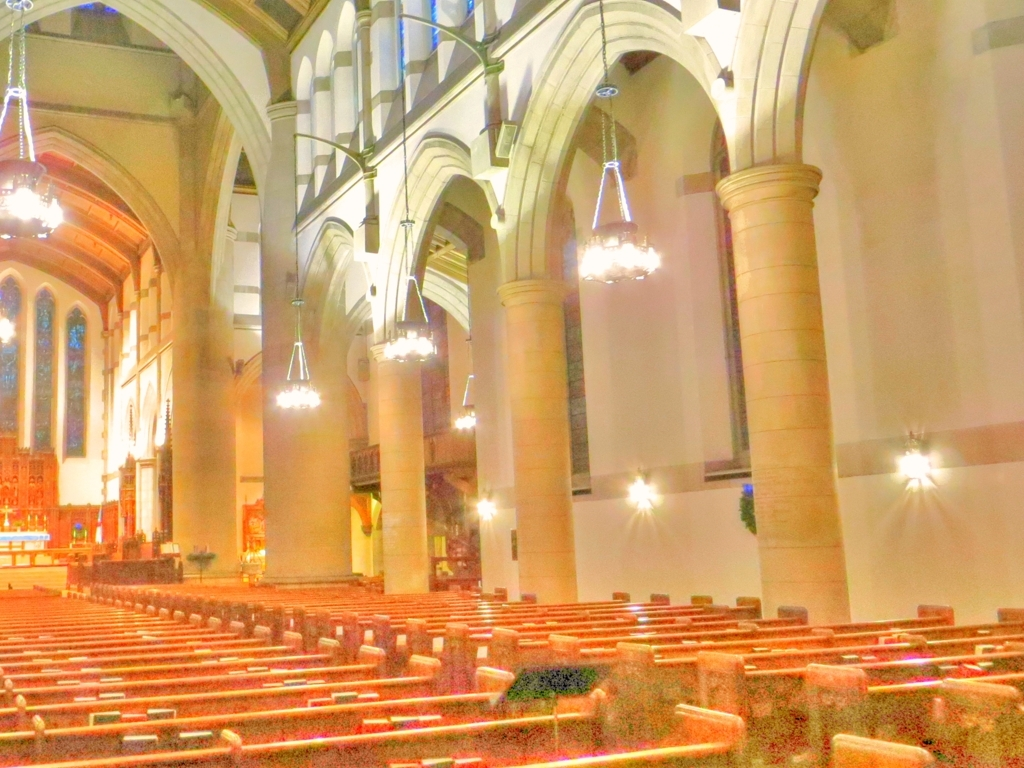What could this place be used for? This appears to be a church or cathedral, likely used for religious services and community gatherings, indicated by the rows of pews, the altars in the front, and the overall serene and organized appearance. 